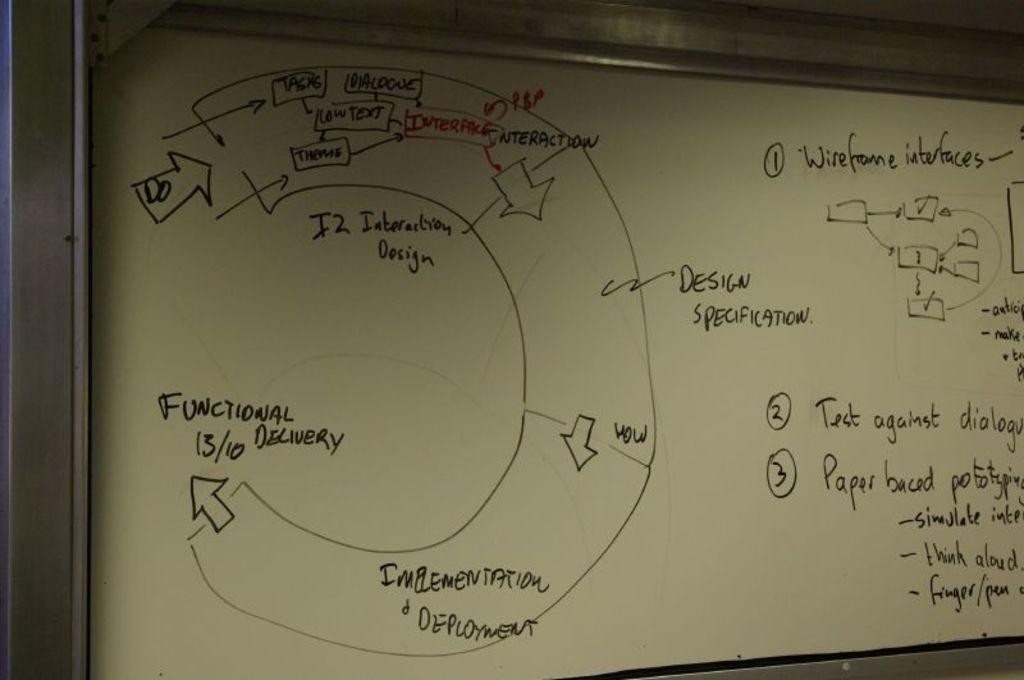<image>
Write a terse but informative summary of the picture. On a whiteboard is much information about design and development. 